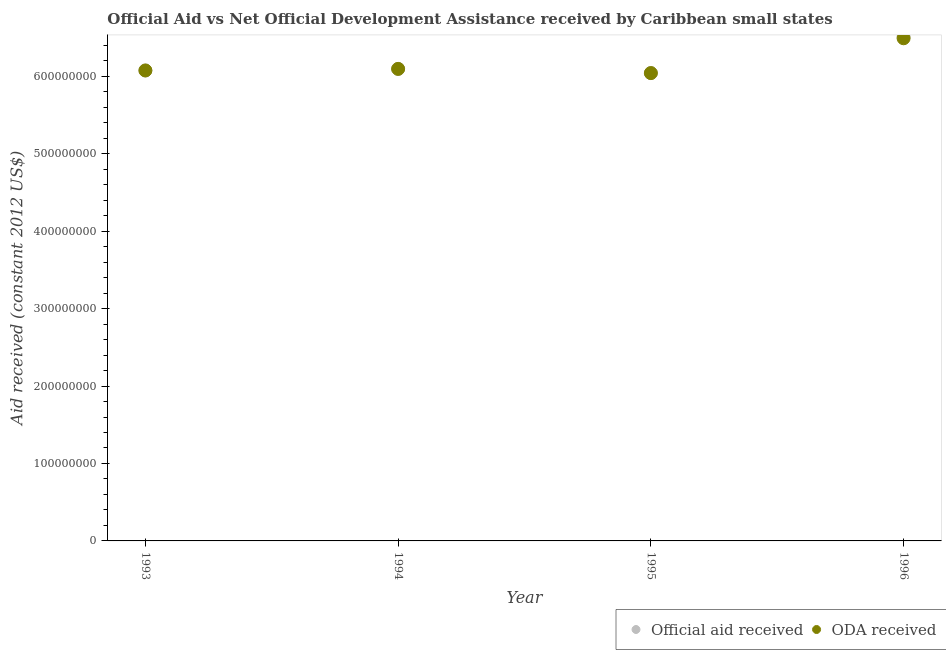How many different coloured dotlines are there?
Your answer should be compact. 2. Is the number of dotlines equal to the number of legend labels?
Provide a succinct answer. Yes. What is the oda received in 1993?
Ensure brevity in your answer.  6.08e+08. Across all years, what is the maximum oda received?
Ensure brevity in your answer.  6.49e+08. Across all years, what is the minimum official aid received?
Give a very brief answer. 6.04e+08. In which year was the oda received maximum?
Your answer should be compact. 1996. In which year was the oda received minimum?
Your answer should be very brief. 1995. What is the total oda received in the graph?
Your response must be concise. 2.47e+09. What is the difference between the oda received in 1993 and that in 1994?
Your response must be concise. -2.04e+06. What is the difference between the official aid received in 1996 and the oda received in 1995?
Provide a short and direct response. 4.70e+07. What is the average official aid received per year?
Provide a short and direct response. 6.18e+08. In how many years, is the official aid received greater than 380000000 US$?
Make the answer very short. 4. What is the ratio of the oda received in 1995 to that in 1996?
Your response must be concise. 0.93. Is the oda received in 1993 less than that in 1994?
Your answer should be compact. Yes. Is the difference between the official aid received in 1993 and 1994 greater than the difference between the oda received in 1993 and 1994?
Provide a short and direct response. No. What is the difference between the highest and the second highest official aid received?
Provide a succinct answer. 4.16e+07. What is the difference between the highest and the lowest official aid received?
Your response must be concise. 4.70e+07. Is the sum of the official aid received in 1994 and 1996 greater than the maximum oda received across all years?
Ensure brevity in your answer.  Yes. Does the official aid received monotonically increase over the years?
Give a very brief answer. No. Is the official aid received strictly greater than the oda received over the years?
Your answer should be compact. No. How many years are there in the graph?
Your response must be concise. 4. What is the difference between two consecutive major ticks on the Y-axis?
Offer a terse response. 1.00e+08. Are the values on the major ticks of Y-axis written in scientific E-notation?
Keep it short and to the point. No. Does the graph contain grids?
Make the answer very short. No. How many legend labels are there?
Your response must be concise. 2. What is the title of the graph?
Provide a short and direct response. Official Aid vs Net Official Development Assistance received by Caribbean small states . Does "Foreign Liabilities" appear as one of the legend labels in the graph?
Your answer should be very brief. No. What is the label or title of the Y-axis?
Ensure brevity in your answer.  Aid received (constant 2012 US$). What is the Aid received (constant 2012 US$) in Official aid received in 1993?
Your answer should be very brief. 6.08e+08. What is the Aid received (constant 2012 US$) in ODA received in 1993?
Provide a succinct answer. 6.08e+08. What is the Aid received (constant 2012 US$) of Official aid received in 1994?
Provide a short and direct response. 6.10e+08. What is the Aid received (constant 2012 US$) of ODA received in 1994?
Your response must be concise. 6.10e+08. What is the Aid received (constant 2012 US$) in Official aid received in 1995?
Offer a terse response. 6.04e+08. What is the Aid received (constant 2012 US$) in ODA received in 1995?
Keep it short and to the point. 6.04e+08. What is the Aid received (constant 2012 US$) in Official aid received in 1996?
Your answer should be very brief. 6.51e+08. What is the Aid received (constant 2012 US$) of ODA received in 1996?
Provide a short and direct response. 6.49e+08. Across all years, what is the maximum Aid received (constant 2012 US$) in Official aid received?
Make the answer very short. 6.51e+08. Across all years, what is the maximum Aid received (constant 2012 US$) of ODA received?
Make the answer very short. 6.49e+08. Across all years, what is the minimum Aid received (constant 2012 US$) of Official aid received?
Ensure brevity in your answer.  6.04e+08. Across all years, what is the minimum Aid received (constant 2012 US$) of ODA received?
Your answer should be very brief. 6.04e+08. What is the total Aid received (constant 2012 US$) in Official aid received in the graph?
Your response must be concise. 2.47e+09. What is the total Aid received (constant 2012 US$) in ODA received in the graph?
Ensure brevity in your answer.  2.47e+09. What is the difference between the Aid received (constant 2012 US$) in Official aid received in 1993 and that in 1994?
Offer a terse response. -2.04e+06. What is the difference between the Aid received (constant 2012 US$) in ODA received in 1993 and that in 1994?
Make the answer very short. -2.04e+06. What is the difference between the Aid received (constant 2012 US$) in Official aid received in 1993 and that in 1995?
Ensure brevity in your answer.  3.37e+06. What is the difference between the Aid received (constant 2012 US$) in ODA received in 1993 and that in 1995?
Your answer should be very brief. 3.37e+06. What is the difference between the Aid received (constant 2012 US$) in Official aid received in 1993 and that in 1996?
Ensure brevity in your answer.  -4.36e+07. What is the difference between the Aid received (constant 2012 US$) of ODA received in 1993 and that in 1996?
Your answer should be very brief. -4.16e+07. What is the difference between the Aid received (constant 2012 US$) in Official aid received in 1994 and that in 1995?
Give a very brief answer. 5.41e+06. What is the difference between the Aid received (constant 2012 US$) in ODA received in 1994 and that in 1995?
Offer a terse response. 5.41e+06. What is the difference between the Aid received (constant 2012 US$) in Official aid received in 1994 and that in 1996?
Provide a short and direct response. -4.16e+07. What is the difference between the Aid received (constant 2012 US$) in ODA received in 1994 and that in 1996?
Your answer should be very brief. -3.95e+07. What is the difference between the Aid received (constant 2012 US$) of Official aid received in 1995 and that in 1996?
Ensure brevity in your answer.  -4.70e+07. What is the difference between the Aid received (constant 2012 US$) in ODA received in 1995 and that in 1996?
Offer a very short reply. -4.50e+07. What is the difference between the Aid received (constant 2012 US$) in Official aid received in 1993 and the Aid received (constant 2012 US$) in ODA received in 1994?
Provide a short and direct response. -2.04e+06. What is the difference between the Aid received (constant 2012 US$) of Official aid received in 1993 and the Aid received (constant 2012 US$) of ODA received in 1995?
Provide a short and direct response. 3.37e+06. What is the difference between the Aid received (constant 2012 US$) in Official aid received in 1993 and the Aid received (constant 2012 US$) in ODA received in 1996?
Offer a terse response. -4.16e+07. What is the difference between the Aid received (constant 2012 US$) in Official aid received in 1994 and the Aid received (constant 2012 US$) in ODA received in 1995?
Provide a succinct answer. 5.41e+06. What is the difference between the Aid received (constant 2012 US$) in Official aid received in 1994 and the Aid received (constant 2012 US$) in ODA received in 1996?
Offer a terse response. -3.95e+07. What is the difference between the Aid received (constant 2012 US$) in Official aid received in 1995 and the Aid received (constant 2012 US$) in ODA received in 1996?
Give a very brief answer. -4.50e+07. What is the average Aid received (constant 2012 US$) in Official aid received per year?
Keep it short and to the point. 6.18e+08. What is the average Aid received (constant 2012 US$) of ODA received per year?
Offer a very short reply. 6.18e+08. In the year 1993, what is the difference between the Aid received (constant 2012 US$) in Official aid received and Aid received (constant 2012 US$) in ODA received?
Provide a short and direct response. 0. In the year 1995, what is the difference between the Aid received (constant 2012 US$) of Official aid received and Aid received (constant 2012 US$) of ODA received?
Your answer should be compact. 0. In the year 1996, what is the difference between the Aid received (constant 2012 US$) in Official aid received and Aid received (constant 2012 US$) in ODA received?
Make the answer very short. 2.04e+06. What is the ratio of the Aid received (constant 2012 US$) in Official aid received in 1993 to that in 1994?
Offer a very short reply. 1. What is the ratio of the Aid received (constant 2012 US$) in ODA received in 1993 to that in 1994?
Provide a short and direct response. 1. What is the ratio of the Aid received (constant 2012 US$) of Official aid received in 1993 to that in 1995?
Your response must be concise. 1.01. What is the ratio of the Aid received (constant 2012 US$) of ODA received in 1993 to that in 1995?
Provide a succinct answer. 1.01. What is the ratio of the Aid received (constant 2012 US$) in Official aid received in 1993 to that in 1996?
Give a very brief answer. 0.93. What is the ratio of the Aid received (constant 2012 US$) of ODA received in 1993 to that in 1996?
Provide a short and direct response. 0.94. What is the ratio of the Aid received (constant 2012 US$) in ODA received in 1994 to that in 1995?
Provide a short and direct response. 1.01. What is the ratio of the Aid received (constant 2012 US$) of Official aid received in 1994 to that in 1996?
Provide a succinct answer. 0.94. What is the ratio of the Aid received (constant 2012 US$) in ODA received in 1994 to that in 1996?
Your answer should be compact. 0.94. What is the ratio of the Aid received (constant 2012 US$) in Official aid received in 1995 to that in 1996?
Offer a terse response. 0.93. What is the ratio of the Aid received (constant 2012 US$) of ODA received in 1995 to that in 1996?
Provide a succinct answer. 0.93. What is the difference between the highest and the second highest Aid received (constant 2012 US$) of Official aid received?
Your answer should be very brief. 4.16e+07. What is the difference between the highest and the second highest Aid received (constant 2012 US$) in ODA received?
Provide a short and direct response. 3.95e+07. What is the difference between the highest and the lowest Aid received (constant 2012 US$) of Official aid received?
Keep it short and to the point. 4.70e+07. What is the difference between the highest and the lowest Aid received (constant 2012 US$) of ODA received?
Your answer should be very brief. 4.50e+07. 